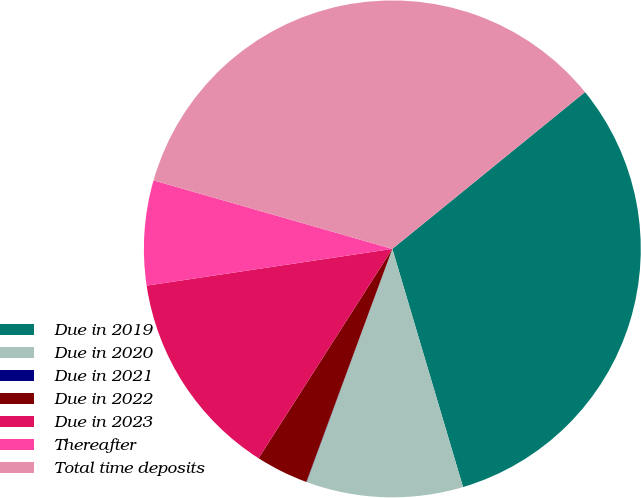Convert chart. <chart><loc_0><loc_0><loc_500><loc_500><pie_chart><fcel>Due in 2019<fcel>Due in 2020<fcel>Due in 2021<fcel>Due in 2022<fcel>Due in 2023<fcel>Thereafter<fcel>Total time deposits<nl><fcel>31.28%<fcel>10.2%<fcel>0.02%<fcel>3.42%<fcel>13.59%<fcel>6.81%<fcel>34.68%<nl></chart> 